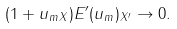<formula> <loc_0><loc_0><loc_500><loc_500>( 1 + \| u _ { m } \| _ { X } ) \| E ^ { \prime } ( u _ { m } ) \| _ { X ^ { \prime } } \to 0 .</formula> 